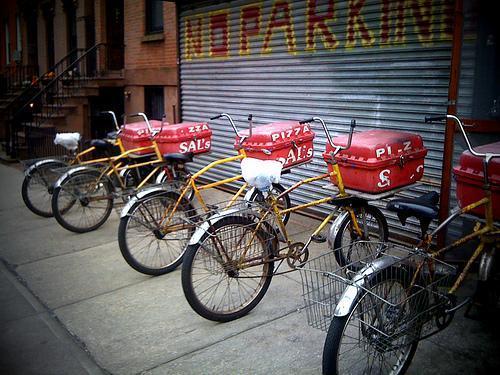How many bikes are here?
Give a very brief answer. 5. How many bikes can be seen?
Give a very brief answer. 5. How many bikes are there?
Give a very brief answer. 5. How many bicycles are there?
Give a very brief answer. 5. How many zebras are facing right in the picture?
Give a very brief answer. 0. 